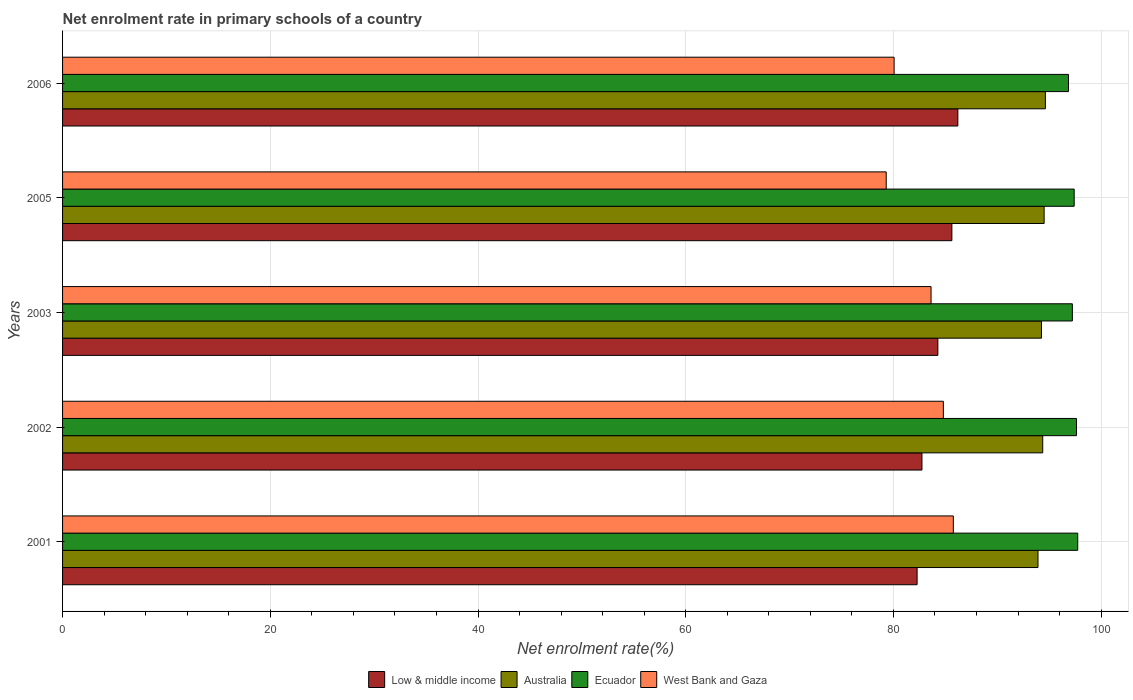How many groups of bars are there?
Provide a succinct answer. 5. Are the number of bars per tick equal to the number of legend labels?
Your response must be concise. Yes. How many bars are there on the 2nd tick from the top?
Offer a very short reply. 4. What is the label of the 3rd group of bars from the top?
Offer a very short reply. 2003. In how many cases, is the number of bars for a given year not equal to the number of legend labels?
Provide a succinct answer. 0. What is the net enrolment rate in primary schools in Australia in 2001?
Your response must be concise. 93.92. Across all years, what is the maximum net enrolment rate in primary schools in Australia?
Offer a very short reply. 94.63. Across all years, what is the minimum net enrolment rate in primary schools in Ecuador?
Make the answer very short. 96.86. What is the total net enrolment rate in primary schools in Ecuador in the graph?
Ensure brevity in your answer.  486.87. What is the difference between the net enrolment rate in primary schools in Ecuador in 2003 and that in 2006?
Your answer should be very brief. 0.37. What is the difference between the net enrolment rate in primary schools in Australia in 2005 and the net enrolment rate in primary schools in Low & middle income in 2003?
Give a very brief answer. 10.23. What is the average net enrolment rate in primary schools in Low & middle income per year?
Offer a terse response. 84.23. In the year 2006, what is the difference between the net enrolment rate in primary schools in Australia and net enrolment rate in primary schools in Low & middle income?
Your response must be concise. 8.43. What is the ratio of the net enrolment rate in primary schools in Ecuador in 2002 to that in 2005?
Provide a succinct answer. 1. Is the difference between the net enrolment rate in primary schools in Australia in 2003 and 2006 greater than the difference between the net enrolment rate in primary schools in Low & middle income in 2003 and 2006?
Offer a terse response. Yes. What is the difference between the highest and the second highest net enrolment rate in primary schools in Australia?
Your answer should be very brief. 0.12. What is the difference between the highest and the lowest net enrolment rate in primary schools in Ecuador?
Your answer should be very brief. 0.89. In how many years, is the net enrolment rate in primary schools in Ecuador greater than the average net enrolment rate in primary schools in Ecuador taken over all years?
Your response must be concise. 3. What does the 1st bar from the top in 2002 represents?
Make the answer very short. West Bank and Gaza. What does the 3rd bar from the bottom in 2001 represents?
Provide a short and direct response. Ecuador. Are all the bars in the graph horizontal?
Provide a succinct answer. Yes. What is the difference between two consecutive major ticks on the X-axis?
Ensure brevity in your answer.  20. Where does the legend appear in the graph?
Offer a very short reply. Bottom center. What is the title of the graph?
Provide a short and direct response. Net enrolment rate in primary schools of a country. What is the label or title of the X-axis?
Ensure brevity in your answer.  Net enrolment rate(%). What is the Net enrolment rate(%) of Low & middle income in 2001?
Ensure brevity in your answer.  82.28. What is the Net enrolment rate(%) in Australia in 2001?
Your response must be concise. 93.92. What is the Net enrolment rate(%) in Ecuador in 2001?
Provide a short and direct response. 97.75. What is the Net enrolment rate(%) of West Bank and Gaza in 2001?
Offer a terse response. 85.77. What is the Net enrolment rate(%) of Low & middle income in 2002?
Provide a short and direct response. 82.75. What is the Net enrolment rate(%) of Australia in 2002?
Provide a short and direct response. 94.38. What is the Net enrolment rate(%) in Ecuador in 2002?
Offer a very short reply. 97.63. What is the Net enrolment rate(%) of West Bank and Gaza in 2002?
Provide a succinct answer. 84.81. What is the Net enrolment rate(%) of Low & middle income in 2003?
Give a very brief answer. 84.28. What is the Net enrolment rate(%) in Australia in 2003?
Ensure brevity in your answer.  94.25. What is the Net enrolment rate(%) of Ecuador in 2003?
Ensure brevity in your answer.  97.23. What is the Net enrolment rate(%) in West Bank and Gaza in 2003?
Make the answer very short. 83.62. What is the Net enrolment rate(%) in Low & middle income in 2005?
Offer a terse response. 85.63. What is the Net enrolment rate(%) of Australia in 2005?
Your answer should be compact. 94.51. What is the Net enrolment rate(%) in Ecuador in 2005?
Give a very brief answer. 97.41. What is the Net enrolment rate(%) in West Bank and Gaza in 2005?
Provide a short and direct response. 79.31. What is the Net enrolment rate(%) in Low & middle income in 2006?
Your answer should be compact. 86.2. What is the Net enrolment rate(%) of Australia in 2006?
Your answer should be compact. 94.63. What is the Net enrolment rate(%) of Ecuador in 2006?
Your answer should be compact. 96.86. What is the Net enrolment rate(%) in West Bank and Gaza in 2006?
Give a very brief answer. 80.07. Across all years, what is the maximum Net enrolment rate(%) in Low & middle income?
Provide a succinct answer. 86.2. Across all years, what is the maximum Net enrolment rate(%) in Australia?
Give a very brief answer. 94.63. Across all years, what is the maximum Net enrolment rate(%) in Ecuador?
Keep it short and to the point. 97.75. Across all years, what is the maximum Net enrolment rate(%) in West Bank and Gaza?
Keep it short and to the point. 85.77. Across all years, what is the minimum Net enrolment rate(%) in Low & middle income?
Your response must be concise. 82.28. Across all years, what is the minimum Net enrolment rate(%) of Australia?
Offer a terse response. 93.92. Across all years, what is the minimum Net enrolment rate(%) in Ecuador?
Offer a very short reply. 96.86. Across all years, what is the minimum Net enrolment rate(%) of West Bank and Gaza?
Offer a terse response. 79.31. What is the total Net enrolment rate(%) of Low & middle income in the graph?
Offer a very short reply. 421.14. What is the total Net enrolment rate(%) of Australia in the graph?
Your answer should be compact. 471.69. What is the total Net enrolment rate(%) in Ecuador in the graph?
Your answer should be compact. 486.87. What is the total Net enrolment rate(%) of West Bank and Gaza in the graph?
Offer a very short reply. 413.57. What is the difference between the Net enrolment rate(%) in Low & middle income in 2001 and that in 2002?
Make the answer very short. -0.47. What is the difference between the Net enrolment rate(%) of Australia in 2001 and that in 2002?
Give a very brief answer. -0.46. What is the difference between the Net enrolment rate(%) in Ecuador in 2001 and that in 2002?
Your answer should be very brief. 0.12. What is the difference between the Net enrolment rate(%) in West Bank and Gaza in 2001 and that in 2002?
Your response must be concise. 0.96. What is the difference between the Net enrolment rate(%) of Low & middle income in 2001 and that in 2003?
Offer a very short reply. -2. What is the difference between the Net enrolment rate(%) in Australia in 2001 and that in 2003?
Make the answer very short. -0.33. What is the difference between the Net enrolment rate(%) of Ecuador in 2001 and that in 2003?
Provide a succinct answer. 0.52. What is the difference between the Net enrolment rate(%) of West Bank and Gaza in 2001 and that in 2003?
Your response must be concise. 2.15. What is the difference between the Net enrolment rate(%) in Low & middle income in 2001 and that in 2005?
Keep it short and to the point. -3.35. What is the difference between the Net enrolment rate(%) of Australia in 2001 and that in 2005?
Provide a short and direct response. -0.59. What is the difference between the Net enrolment rate(%) of Ecuador in 2001 and that in 2005?
Provide a short and direct response. 0.34. What is the difference between the Net enrolment rate(%) of West Bank and Gaza in 2001 and that in 2005?
Your answer should be compact. 6.46. What is the difference between the Net enrolment rate(%) in Low & middle income in 2001 and that in 2006?
Give a very brief answer. -3.92. What is the difference between the Net enrolment rate(%) in Australia in 2001 and that in 2006?
Provide a succinct answer. -0.71. What is the difference between the Net enrolment rate(%) of Ecuador in 2001 and that in 2006?
Make the answer very short. 0.89. What is the difference between the Net enrolment rate(%) of West Bank and Gaza in 2001 and that in 2006?
Ensure brevity in your answer.  5.7. What is the difference between the Net enrolment rate(%) of Low & middle income in 2002 and that in 2003?
Give a very brief answer. -1.53. What is the difference between the Net enrolment rate(%) of Australia in 2002 and that in 2003?
Ensure brevity in your answer.  0.12. What is the difference between the Net enrolment rate(%) in Ecuador in 2002 and that in 2003?
Your answer should be very brief. 0.4. What is the difference between the Net enrolment rate(%) of West Bank and Gaza in 2002 and that in 2003?
Your answer should be very brief. 1.19. What is the difference between the Net enrolment rate(%) in Low & middle income in 2002 and that in 2005?
Ensure brevity in your answer.  -2.88. What is the difference between the Net enrolment rate(%) in Australia in 2002 and that in 2005?
Your answer should be compact. -0.14. What is the difference between the Net enrolment rate(%) of Ecuador in 2002 and that in 2005?
Make the answer very short. 0.22. What is the difference between the Net enrolment rate(%) of West Bank and Gaza in 2002 and that in 2005?
Provide a short and direct response. 5.5. What is the difference between the Net enrolment rate(%) in Low & middle income in 2002 and that in 2006?
Offer a very short reply. -3.46. What is the difference between the Net enrolment rate(%) in Australia in 2002 and that in 2006?
Offer a terse response. -0.26. What is the difference between the Net enrolment rate(%) of Ecuador in 2002 and that in 2006?
Offer a very short reply. 0.77. What is the difference between the Net enrolment rate(%) of West Bank and Gaza in 2002 and that in 2006?
Your response must be concise. 4.74. What is the difference between the Net enrolment rate(%) in Low & middle income in 2003 and that in 2005?
Offer a very short reply. -1.35. What is the difference between the Net enrolment rate(%) of Australia in 2003 and that in 2005?
Keep it short and to the point. -0.26. What is the difference between the Net enrolment rate(%) in Ecuador in 2003 and that in 2005?
Give a very brief answer. -0.18. What is the difference between the Net enrolment rate(%) in West Bank and Gaza in 2003 and that in 2005?
Offer a terse response. 4.32. What is the difference between the Net enrolment rate(%) in Low & middle income in 2003 and that in 2006?
Offer a terse response. -1.93. What is the difference between the Net enrolment rate(%) of Australia in 2003 and that in 2006?
Give a very brief answer. -0.38. What is the difference between the Net enrolment rate(%) of Ecuador in 2003 and that in 2006?
Ensure brevity in your answer.  0.37. What is the difference between the Net enrolment rate(%) of West Bank and Gaza in 2003 and that in 2006?
Provide a succinct answer. 3.56. What is the difference between the Net enrolment rate(%) of Low & middle income in 2005 and that in 2006?
Offer a terse response. -0.57. What is the difference between the Net enrolment rate(%) in Australia in 2005 and that in 2006?
Your answer should be very brief. -0.12. What is the difference between the Net enrolment rate(%) of Ecuador in 2005 and that in 2006?
Your answer should be very brief. 0.55. What is the difference between the Net enrolment rate(%) in West Bank and Gaza in 2005 and that in 2006?
Provide a short and direct response. -0.76. What is the difference between the Net enrolment rate(%) of Low & middle income in 2001 and the Net enrolment rate(%) of Australia in 2002?
Your answer should be very brief. -12.09. What is the difference between the Net enrolment rate(%) in Low & middle income in 2001 and the Net enrolment rate(%) in Ecuador in 2002?
Keep it short and to the point. -15.35. What is the difference between the Net enrolment rate(%) in Low & middle income in 2001 and the Net enrolment rate(%) in West Bank and Gaza in 2002?
Keep it short and to the point. -2.53. What is the difference between the Net enrolment rate(%) of Australia in 2001 and the Net enrolment rate(%) of Ecuador in 2002?
Give a very brief answer. -3.71. What is the difference between the Net enrolment rate(%) of Australia in 2001 and the Net enrolment rate(%) of West Bank and Gaza in 2002?
Give a very brief answer. 9.11. What is the difference between the Net enrolment rate(%) of Ecuador in 2001 and the Net enrolment rate(%) of West Bank and Gaza in 2002?
Offer a terse response. 12.94. What is the difference between the Net enrolment rate(%) of Low & middle income in 2001 and the Net enrolment rate(%) of Australia in 2003?
Keep it short and to the point. -11.97. What is the difference between the Net enrolment rate(%) of Low & middle income in 2001 and the Net enrolment rate(%) of Ecuador in 2003?
Keep it short and to the point. -14.95. What is the difference between the Net enrolment rate(%) of Low & middle income in 2001 and the Net enrolment rate(%) of West Bank and Gaza in 2003?
Give a very brief answer. -1.34. What is the difference between the Net enrolment rate(%) of Australia in 2001 and the Net enrolment rate(%) of Ecuador in 2003?
Give a very brief answer. -3.31. What is the difference between the Net enrolment rate(%) of Australia in 2001 and the Net enrolment rate(%) of West Bank and Gaza in 2003?
Offer a very short reply. 10.3. What is the difference between the Net enrolment rate(%) in Ecuador in 2001 and the Net enrolment rate(%) in West Bank and Gaza in 2003?
Your response must be concise. 14.12. What is the difference between the Net enrolment rate(%) of Low & middle income in 2001 and the Net enrolment rate(%) of Australia in 2005?
Your answer should be compact. -12.23. What is the difference between the Net enrolment rate(%) of Low & middle income in 2001 and the Net enrolment rate(%) of Ecuador in 2005?
Your answer should be very brief. -15.12. What is the difference between the Net enrolment rate(%) of Low & middle income in 2001 and the Net enrolment rate(%) of West Bank and Gaza in 2005?
Ensure brevity in your answer.  2.97. What is the difference between the Net enrolment rate(%) in Australia in 2001 and the Net enrolment rate(%) in Ecuador in 2005?
Give a very brief answer. -3.48. What is the difference between the Net enrolment rate(%) in Australia in 2001 and the Net enrolment rate(%) in West Bank and Gaza in 2005?
Provide a succinct answer. 14.61. What is the difference between the Net enrolment rate(%) in Ecuador in 2001 and the Net enrolment rate(%) in West Bank and Gaza in 2005?
Offer a very short reply. 18.44. What is the difference between the Net enrolment rate(%) of Low & middle income in 2001 and the Net enrolment rate(%) of Australia in 2006?
Provide a succinct answer. -12.35. What is the difference between the Net enrolment rate(%) of Low & middle income in 2001 and the Net enrolment rate(%) of Ecuador in 2006?
Make the answer very short. -14.58. What is the difference between the Net enrolment rate(%) in Low & middle income in 2001 and the Net enrolment rate(%) in West Bank and Gaza in 2006?
Provide a succinct answer. 2.21. What is the difference between the Net enrolment rate(%) of Australia in 2001 and the Net enrolment rate(%) of Ecuador in 2006?
Keep it short and to the point. -2.94. What is the difference between the Net enrolment rate(%) of Australia in 2001 and the Net enrolment rate(%) of West Bank and Gaza in 2006?
Provide a succinct answer. 13.85. What is the difference between the Net enrolment rate(%) in Ecuador in 2001 and the Net enrolment rate(%) in West Bank and Gaza in 2006?
Offer a terse response. 17.68. What is the difference between the Net enrolment rate(%) in Low & middle income in 2002 and the Net enrolment rate(%) in Australia in 2003?
Provide a succinct answer. -11.51. What is the difference between the Net enrolment rate(%) in Low & middle income in 2002 and the Net enrolment rate(%) in Ecuador in 2003?
Your response must be concise. -14.48. What is the difference between the Net enrolment rate(%) in Low & middle income in 2002 and the Net enrolment rate(%) in West Bank and Gaza in 2003?
Your answer should be compact. -0.88. What is the difference between the Net enrolment rate(%) in Australia in 2002 and the Net enrolment rate(%) in Ecuador in 2003?
Your response must be concise. -2.85. What is the difference between the Net enrolment rate(%) in Australia in 2002 and the Net enrolment rate(%) in West Bank and Gaza in 2003?
Your answer should be compact. 10.75. What is the difference between the Net enrolment rate(%) in Ecuador in 2002 and the Net enrolment rate(%) in West Bank and Gaza in 2003?
Provide a short and direct response. 14.01. What is the difference between the Net enrolment rate(%) of Low & middle income in 2002 and the Net enrolment rate(%) of Australia in 2005?
Ensure brevity in your answer.  -11.76. What is the difference between the Net enrolment rate(%) in Low & middle income in 2002 and the Net enrolment rate(%) in Ecuador in 2005?
Provide a succinct answer. -14.66. What is the difference between the Net enrolment rate(%) of Low & middle income in 2002 and the Net enrolment rate(%) of West Bank and Gaza in 2005?
Provide a short and direct response. 3.44. What is the difference between the Net enrolment rate(%) of Australia in 2002 and the Net enrolment rate(%) of Ecuador in 2005?
Ensure brevity in your answer.  -3.03. What is the difference between the Net enrolment rate(%) of Australia in 2002 and the Net enrolment rate(%) of West Bank and Gaza in 2005?
Provide a succinct answer. 15.07. What is the difference between the Net enrolment rate(%) in Ecuador in 2002 and the Net enrolment rate(%) in West Bank and Gaza in 2005?
Keep it short and to the point. 18.32. What is the difference between the Net enrolment rate(%) in Low & middle income in 2002 and the Net enrolment rate(%) in Australia in 2006?
Ensure brevity in your answer.  -11.89. What is the difference between the Net enrolment rate(%) of Low & middle income in 2002 and the Net enrolment rate(%) of Ecuador in 2006?
Keep it short and to the point. -14.11. What is the difference between the Net enrolment rate(%) in Low & middle income in 2002 and the Net enrolment rate(%) in West Bank and Gaza in 2006?
Provide a short and direct response. 2.68. What is the difference between the Net enrolment rate(%) in Australia in 2002 and the Net enrolment rate(%) in Ecuador in 2006?
Offer a terse response. -2.48. What is the difference between the Net enrolment rate(%) of Australia in 2002 and the Net enrolment rate(%) of West Bank and Gaza in 2006?
Make the answer very short. 14.31. What is the difference between the Net enrolment rate(%) of Ecuador in 2002 and the Net enrolment rate(%) of West Bank and Gaza in 2006?
Your answer should be very brief. 17.56. What is the difference between the Net enrolment rate(%) of Low & middle income in 2003 and the Net enrolment rate(%) of Australia in 2005?
Give a very brief answer. -10.23. What is the difference between the Net enrolment rate(%) in Low & middle income in 2003 and the Net enrolment rate(%) in Ecuador in 2005?
Offer a very short reply. -13.13. What is the difference between the Net enrolment rate(%) of Low & middle income in 2003 and the Net enrolment rate(%) of West Bank and Gaza in 2005?
Provide a succinct answer. 4.97. What is the difference between the Net enrolment rate(%) in Australia in 2003 and the Net enrolment rate(%) in Ecuador in 2005?
Your answer should be compact. -3.15. What is the difference between the Net enrolment rate(%) of Australia in 2003 and the Net enrolment rate(%) of West Bank and Gaza in 2005?
Your answer should be very brief. 14.95. What is the difference between the Net enrolment rate(%) in Ecuador in 2003 and the Net enrolment rate(%) in West Bank and Gaza in 2005?
Your answer should be compact. 17.92. What is the difference between the Net enrolment rate(%) in Low & middle income in 2003 and the Net enrolment rate(%) in Australia in 2006?
Your response must be concise. -10.35. What is the difference between the Net enrolment rate(%) of Low & middle income in 2003 and the Net enrolment rate(%) of Ecuador in 2006?
Make the answer very short. -12.58. What is the difference between the Net enrolment rate(%) in Low & middle income in 2003 and the Net enrolment rate(%) in West Bank and Gaza in 2006?
Offer a very short reply. 4.21. What is the difference between the Net enrolment rate(%) in Australia in 2003 and the Net enrolment rate(%) in Ecuador in 2006?
Your response must be concise. -2.6. What is the difference between the Net enrolment rate(%) of Australia in 2003 and the Net enrolment rate(%) of West Bank and Gaza in 2006?
Your response must be concise. 14.19. What is the difference between the Net enrolment rate(%) in Ecuador in 2003 and the Net enrolment rate(%) in West Bank and Gaza in 2006?
Provide a succinct answer. 17.16. What is the difference between the Net enrolment rate(%) of Low & middle income in 2005 and the Net enrolment rate(%) of Australia in 2006?
Ensure brevity in your answer.  -9. What is the difference between the Net enrolment rate(%) of Low & middle income in 2005 and the Net enrolment rate(%) of Ecuador in 2006?
Your answer should be compact. -11.23. What is the difference between the Net enrolment rate(%) in Low & middle income in 2005 and the Net enrolment rate(%) in West Bank and Gaza in 2006?
Ensure brevity in your answer.  5.56. What is the difference between the Net enrolment rate(%) in Australia in 2005 and the Net enrolment rate(%) in Ecuador in 2006?
Give a very brief answer. -2.35. What is the difference between the Net enrolment rate(%) in Australia in 2005 and the Net enrolment rate(%) in West Bank and Gaza in 2006?
Keep it short and to the point. 14.44. What is the difference between the Net enrolment rate(%) of Ecuador in 2005 and the Net enrolment rate(%) of West Bank and Gaza in 2006?
Provide a short and direct response. 17.34. What is the average Net enrolment rate(%) in Low & middle income per year?
Your answer should be compact. 84.23. What is the average Net enrolment rate(%) of Australia per year?
Your answer should be compact. 94.34. What is the average Net enrolment rate(%) in Ecuador per year?
Offer a very short reply. 97.37. What is the average Net enrolment rate(%) in West Bank and Gaza per year?
Your answer should be very brief. 82.71. In the year 2001, what is the difference between the Net enrolment rate(%) of Low & middle income and Net enrolment rate(%) of Australia?
Your answer should be very brief. -11.64. In the year 2001, what is the difference between the Net enrolment rate(%) in Low & middle income and Net enrolment rate(%) in Ecuador?
Your response must be concise. -15.47. In the year 2001, what is the difference between the Net enrolment rate(%) of Low & middle income and Net enrolment rate(%) of West Bank and Gaza?
Ensure brevity in your answer.  -3.49. In the year 2001, what is the difference between the Net enrolment rate(%) of Australia and Net enrolment rate(%) of Ecuador?
Your answer should be very brief. -3.83. In the year 2001, what is the difference between the Net enrolment rate(%) in Australia and Net enrolment rate(%) in West Bank and Gaza?
Offer a very short reply. 8.15. In the year 2001, what is the difference between the Net enrolment rate(%) in Ecuador and Net enrolment rate(%) in West Bank and Gaza?
Ensure brevity in your answer.  11.98. In the year 2002, what is the difference between the Net enrolment rate(%) in Low & middle income and Net enrolment rate(%) in Australia?
Offer a terse response. -11.63. In the year 2002, what is the difference between the Net enrolment rate(%) of Low & middle income and Net enrolment rate(%) of Ecuador?
Provide a short and direct response. -14.88. In the year 2002, what is the difference between the Net enrolment rate(%) in Low & middle income and Net enrolment rate(%) in West Bank and Gaza?
Offer a very short reply. -2.06. In the year 2002, what is the difference between the Net enrolment rate(%) in Australia and Net enrolment rate(%) in Ecuador?
Ensure brevity in your answer.  -3.25. In the year 2002, what is the difference between the Net enrolment rate(%) in Australia and Net enrolment rate(%) in West Bank and Gaza?
Make the answer very short. 9.57. In the year 2002, what is the difference between the Net enrolment rate(%) of Ecuador and Net enrolment rate(%) of West Bank and Gaza?
Make the answer very short. 12.82. In the year 2003, what is the difference between the Net enrolment rate(%) in Low & middle income and Net enrolment rate(%) in Australia?
Keep it short and to the point. -9.98. In the year 2003, what is the difference between the Net enrolment rate(%) of Low & middle income and Net enrolment rate(%) of Ecuador?
Provide a succinct answer. -12.95. In the year 2003, what is the difference between the Net enrolment rate(%) in Low & middle income and Net enrolment rate(%) in West Bank and Gaza?
Give a very brief answer. 0.66. In the year 2003, what is the difference between the Net enrolment rate(%) in Australia and Net enrolment rate(%) in Ecuador?
Keep it short and to the point. -2.97. In the year 2003, what is the difference between the Net enrolment rate(%) of Australia and Net enrolment rate(%) of West Bank and Gaza?
Keep it short and to the point. 10.63. In the year 2003, what is the difference between the Net enrolment rate(%) in Ecuador and Net enrolment rate(%) in West Bank and Gaza?
Make the answer very short. 13.61. In the year 2005, what is the difference between the Net enrolment rate(%) in Low & middle income and Net enrolment rate(%) in Australia?
Provide a succinct answer. -8.88. In the year 2005, what is the difference between the Net enrolment rate(%) of Low & middle income and Net enrolment rate(%) of Ecuador?
Keep it short and to the point. -11.78. In the year 2005, what is the difference between the Net enrolment rate(%) of Low & middle income and Net enrolment rate(%) of West Bank and Gaza?
Provide a short and direct response. 6.32. In the year 2005, what is the difference between the Net enrolment rate(%) of Australia and Net enrolment rate(%) of Ecuador?
Your answer should be very brief. -2.89. In the year 2005, what is the difference between the Net enrolment rate(%) in Australia and Net enrolment rate(%) in West Bank and Gaza?
Provide a succinct answer. 15.2. In the year 2005, what is the difference between the Net enrolment rate(%) in Ecuador and Net enrolment rate(%) in West Bank and Gaza?
Your response must be concise. 18.1. In the year 2006, what is the difference between the Net enrolment rate(%) of Low & middle income and Net enrolment rate(%) of Australia?
Keep it short and to the point. -8.43. In the year 2006, what is the difference between the Net enrolment rate(%) in Low & middle income and Net enrolment rate(%) in Ecuador?
Your answer should be compact. -10.65. In the year 2006, what is the difference between the Net enrolment rate(%) in Low & middle income and Net enrolment rate(%) in West Bank and Gaza?
Offer a very short reply. 6.14. In the year 2006, what is the difference between the Net enrolment rate(%) of Australia and Net enrolment rate(%) of Ecuador?
Your answer should be very brief. -2.23. In the year 2006, what is the difference between the Net enrolment rate(%) of Australia and Net enrolment rate(%) of West Bank and Gaza?
Give a very brief answer. 14.57. In the year 2006, what is the difference between the Net enrolment rate(%) in Ecuador and Net enrolment rate(%) in West Bank and Gaza?
Ensure brevity in your answer.  16.79. What is the ratio of the Net enrolment rate(%) in Low & middle income in 2001 to that in 2002?
Provide a short and direct response. 0.99. What is the ratio of the Net enrolment rate(%) of Ecuador in 2001 to that in 2002?
Your response must be concise. 1. What is the ratio of the Net enrolment rate(%) of West Bank and Gaza in 2001 to that in 2002?
Provide a succinct answer. 1.01. What is the ratio of the Net enrolment rate(%) of Low & middle income in 2001 to that in 2003?
Ensure brevity in your answer.  0.98. What is the ratio of the Net enrolment rate(%) in Australia in 2001 to that in 2003?
Offer a terse response. 1. What is the ratio of the Net enrolment rate(%) of West Bank and Gaza in 2001 to that in 2003?
Keep it short and to the point. 1.03. What is the ratio of the Net enrolment rate(%) of Low & middle income in 2001 to that in 2005?
Make the answer very short. 0.96. What is the ratio of the Net enrolment rate(%) in Australia in 2001 to that in 2005?
Your answer should be compact. 0.99. What is the ratio of the Net enrolment rate(%) of Ecuador in 2001 to that in 2005?
Make the answer very short. 1. What is the ratio of the Net enrolment rate(%) in West Bank and Gaza in 2001 to that in 2005?
Give a very brief answer. 1.08. What is the ratio of the Net enrolment rate(%) of Low & middle income in 2001 to that in 2006?
Give a very brief answer. 0.95. What is the ratio of the Net enrolment rate(%) in Australia in 2001 to that in 2006?
Keep it short and to the point. 0.99. What is the ratio of the Net enrolment rate(%) in Ecuador in 2001 to that in 2006?
Your answer should be very brief. 1.01. What is the ratio of the Net enrolment rate(%) in West Bank and Gaza in 2001 to that in 2006?
Offer a terse response. 1.07. What is the ratio of the Net enrolment rate(%) of Low & middle income in 2002 to that in 2003?
Your answer should be very brief. 0.98. What is the ratio of the Net enrolment rate(%) of Australia in 2002 to that in 2003?
Keep it short and to the point. 1. What is the ratio of the Net enrolment rate(%) of Ecuador in 2002 to that in 2003?
Provide a short and direct response. 1. What is the ratio of the Net enrolment rate(%) of West Bank and Gaza in 2002 to that in 2003?
Your response must be concise. 1.01. What is the ratio of the Net enrolment rate(%) of Low & middle income in 2002 to that in 2005?
Give a very brief answer. 0.97. What is the ratio of the Net enrolment rate(%) in Ecuador in 2002 to that in 2005?
Provide a succinct answer. 1. What is the ratio of the Net enrolment rate(%) in West Bank and Gaza in 2002 to that in 2005?
Ensure brevity in your answer.  1.07. What is the ratio of the Net enrolment rate(%) of Low & middle income in 2002 to that in 2006?
Provide a succinct answer. 0.96. What is the ratio of the Net enrolment rate(%) of Ecuador in 2002 to that in 2006?
Your answer should be compact. 1.01. What is the ratio of the Net enrolment rate(%) in West Bank and Gaza in 2002 to that in 2006?
Ensure brevity in your answer.  1.06. What is the ratio of the Net enrolment rate(%) in Low & middle income in 2003 to that in 2005?
Provide a short and direct response. 0.98. What is the ratio of the Net enrolment rate(%) of Ecuador in 2003 to that in 2005?
Your answer should be compact. 1. What is the ratio of the Net enrolment rate(%) in West Bank and Gaza in 2003 to that in 2005?
Keep it short and to the point. 1.05. What is the ratio of the Net enrolment rate(%) of Low & middle income in 2003 to that in 2006?
Offer a very short reply. 0.98. What is the ratio of the Net enrolment rate(%) of Ecuador in 2003 to that in 2006?
Give a very brief answer. 1. What is the ratio of the Net enrolment rate(%) of West Bank and Gaza in 2003 to that in 2006?
Provide a succinct answer. 1.04. What is the ratio of the Net enrolment rate(%) in Australia in 2005 to that in 2006?
Offer a very short reply. 1. What is the ratio of the Net enrolment rate(%) in Ecuador in 2005 to that in 2006?
Your response must be concise. 1.01. What is the difference between the highest and the second highest Net enrolment rate(%) of Low & middle income?
Offer a very short reply. 0.57. What is the difference between the highest and the second highest Net enrolment rate(%) of Australia?
Your answer should be very brief. 0.12. What is the difference between the highest and the second highest Net enrolment rate(%) of Ecuador?
Ensure brevity in your answer.  0.12. What is the difference between the highest and the second highest Net enrolment rate(%) in West Bank and Gaza?
Ensure brevity in your answer.  0.96. What is the difference between the highest and the lowest Net enrolment rate(%) in Low & middle income?
Keep it short and to the point. 3.92. What is the difference between the highest and the lowest Net enrolment rate(%) in Australia?
Offer a terse response. 0.71. What is the difference between the highest and the lowest Net enrolment rate(%) in Ecuador?
Ensure brevity in your answer.  0.89. What is the difference between the highest and the lowest Net enrolment rate(%) of West Bank and Gaza?
Offer a very short reply. 6.46. 